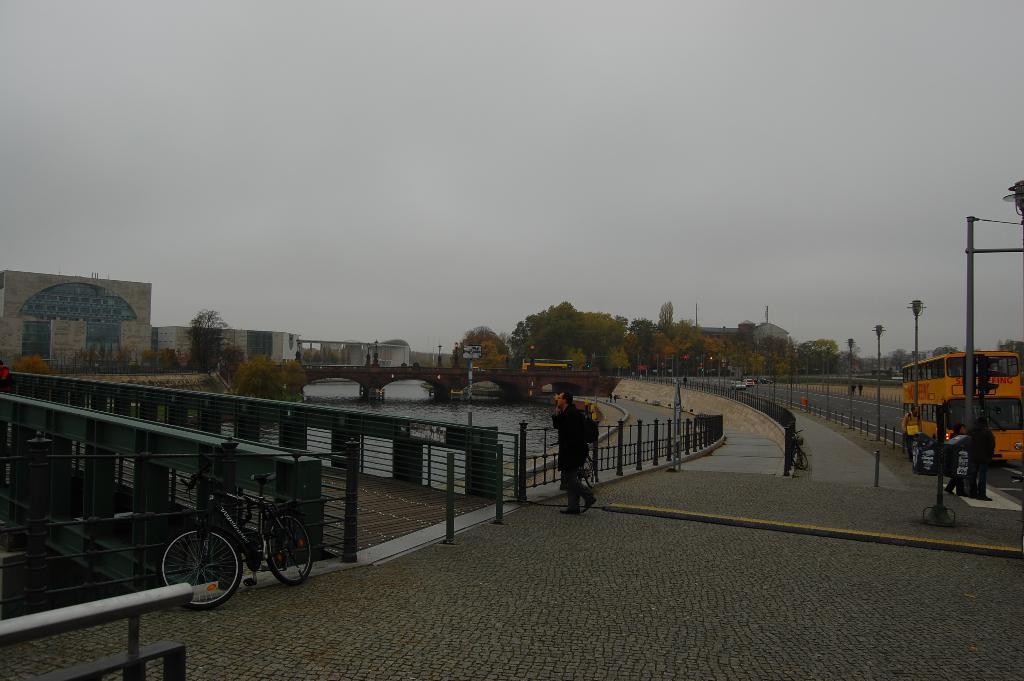Can you describe this image briefly? In this picture we can see vehicles, bicycles and few people on the ground, here we can see poles, bridgewater, buildings and trees and in the background we can see the sky. 